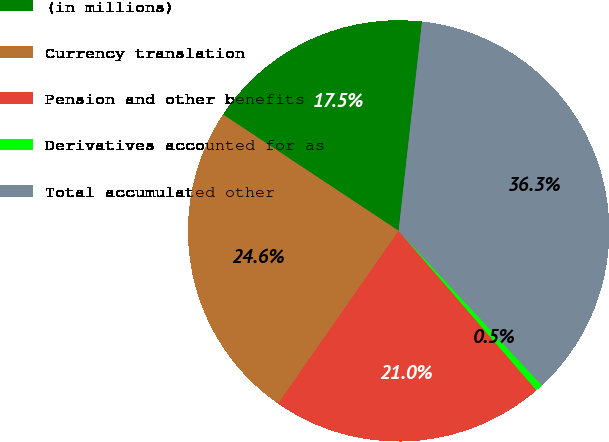Convert chart. <chart><loc_0><loc_0><loc_500><loc_500><pie_chart><fcel>(in millions)<fcel>Currency translation<fcel>Pension and other benefits<fcel>Derivatives accounted for as<fcel>Total accumulated other<nl><fcel>17.46%<fcel>24.62%<fcel>21.04%<fcel>0.55%<fcel>36.34%<nl></chart> 